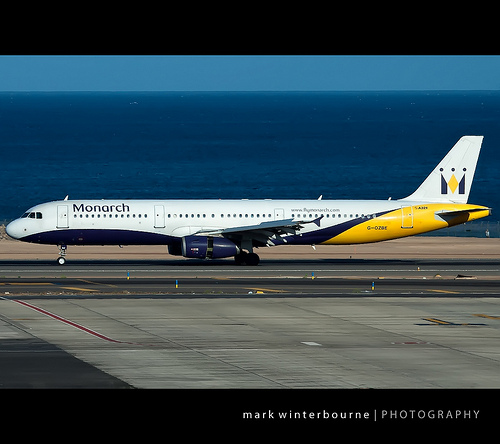How does the background of the image contribute to the overall composition? The background features a calm, blue sea and a clear sky, which contrasts nicely with the vibrant colors of the plane. This serene backdrop highlights the plane, making it the focal point of the image and creating a sense of tranquility and vastness. Imagine this scene at night. Describe what changes you would expect to see. At night, the image would be transformed by the absence of daylight. The plane and runway lights would illuminate the scene, casting a warm glow on the aircraft and ground. The dark sea would become a reflective surface, mirroring the runway lights. The sky might feature a canopy of stars, adding a touch of wonder to the composition. Overall, the scene would adopt a more dramatic and almost magical atmosphere, with the lights standing out against the darkness. Can you create a realistic scenario involving this plane? Certainly! One realistic scenario could involve this Monarch plane preparing for an early morning flight from a coastal airport. The ground crew performs their final checks, refueling the aircraft and loading passengers' luggage. The first light of dawn begins to break over the horizon as boarding commences, with travelers excitedly finding their seats. The pilot and co-pilot, having completed their pre-flight checks, welcome passengers on board and prepare for a smooth takeoff towards the next destination, a bustling city where this flight will mark the beginning of many adventures for its passengers. Based on the image, describe a casual scene that could be taking place in the airport terminal. Inside the airport terminal, travelers could be seen sitting comfortably with their families, sipping coffee and chatting about their upcoming trip. Kids might be glued to the windows, watching the planes take off and land with excitement. Business travelers could be typing away on their laptops, getting some last-minute work done before their flight. The ambient sound of announcements and rolling suitcases creates a busy yet organized atmosphere, with everyone eagerly awaiting their journey. 